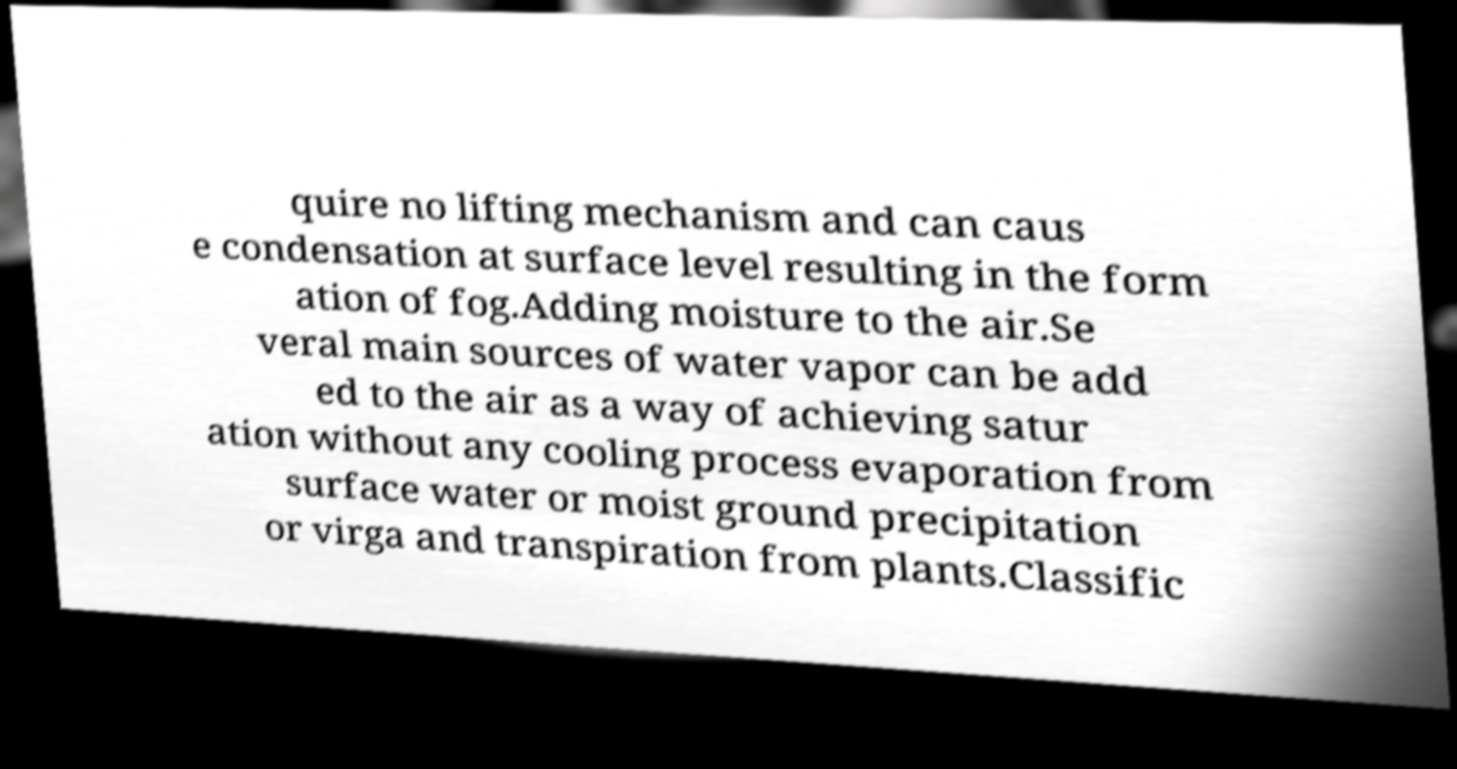Please identify and transcribe the text found in this image. quire no lifting mechanism and can caus e condensation at surface level resulting in the form ation of fog.Adding moisture to the air.Se veral main sources of water vapor can be add ed to the air as a way of achieving satur ation without any cooling process evaporation from surface water or moist ground precipitation or virga and transpiration from plants.Classific 